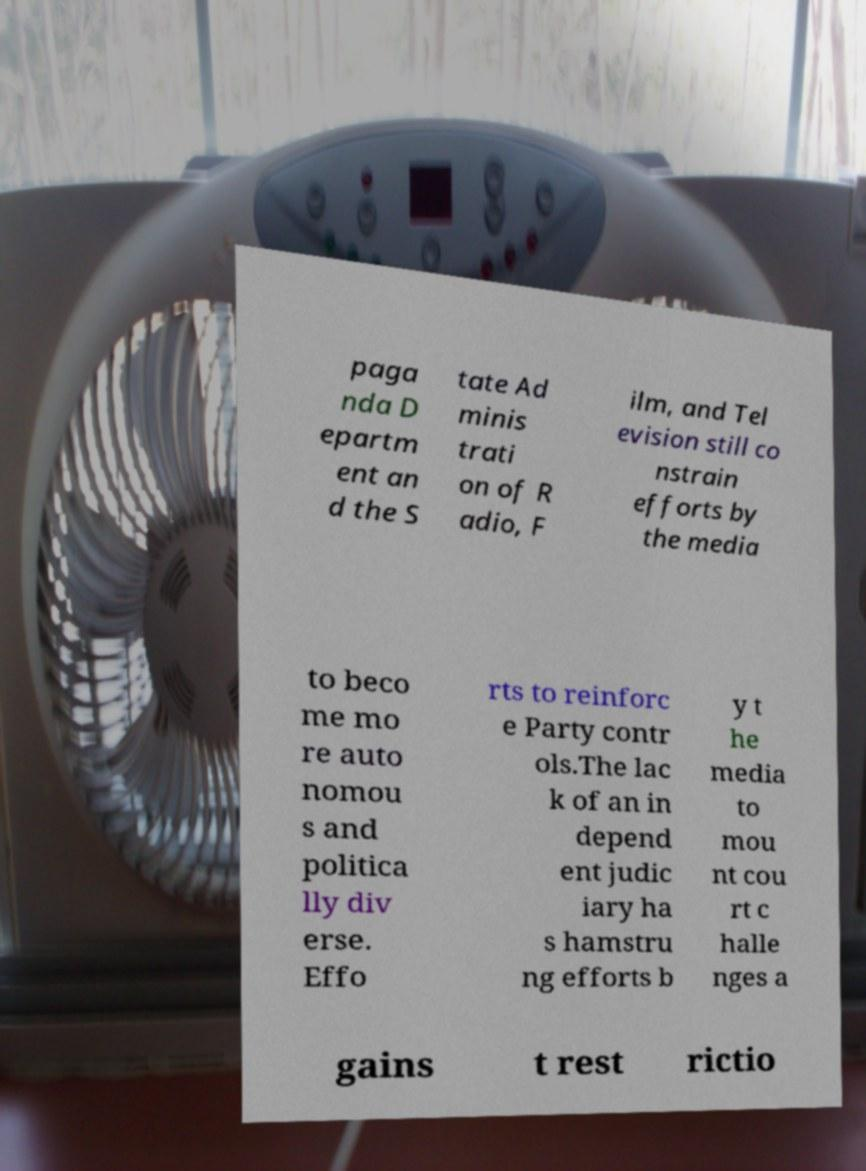Can you read and provide the text displayed in the image?This photo seems to have some interesting text. Can you extract and type it out for me? paga nda D epartm ent an d the S tate Ad minis trati on of R adio, F ilm, and Tel evision still co nstrain efforts by the media to beco me mo re auto nomou s and politica lly div erse. Effo rts to reinforc e Party contr ols.The lac k of an in depend ent judic iary ha s hamstru ng efforts b y t he media to mou nt cou rt c halle nges a gains t rest rictio 